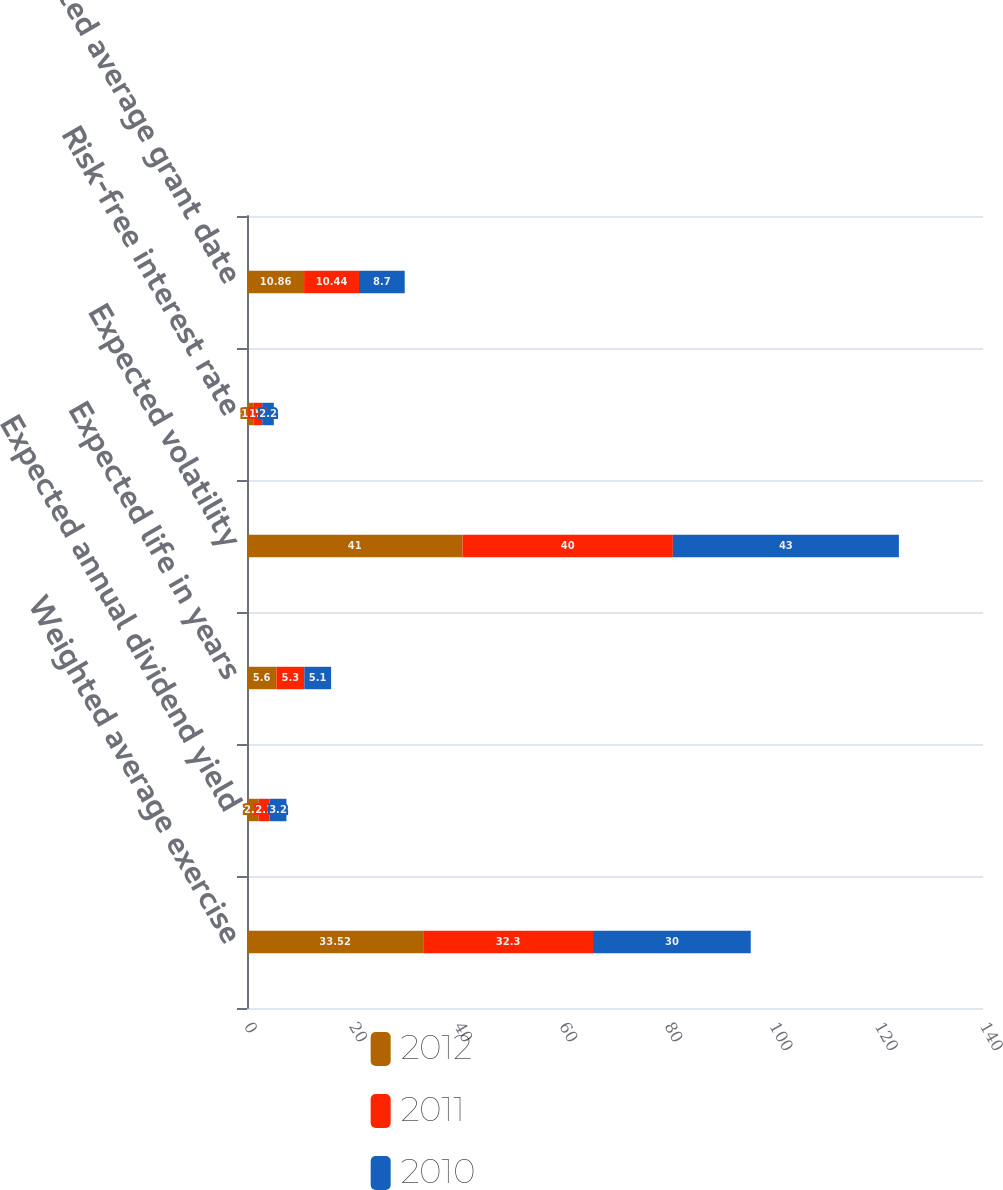<chart> <loc_0><loc_0><loc_500><loc_500><stacked_bar_chart><ecel><fcel>Weighted average exercise<fcel>Expected annual dividend yield<fcel>Expected life in years<fcel>Expected volatility<fcel>Risk-free interest rate<fcel>Weighted average grant date<nl><fcel>2012<fcel>33.52<fcel>2.2<fcel>5.6<fcel>41<fcel>1.2<fcel>10.86<nl><fcel>2011<fcel>32.3<fcel>2.1<fcel>5.3<fcel>40<fcel>1.7<fcel>10.44<nl><fcel>2010<fcel>30<fcel>3.2<fcel>5.1<fcel>43<fcel>2.2<fcel>8.7<nl></chart> 